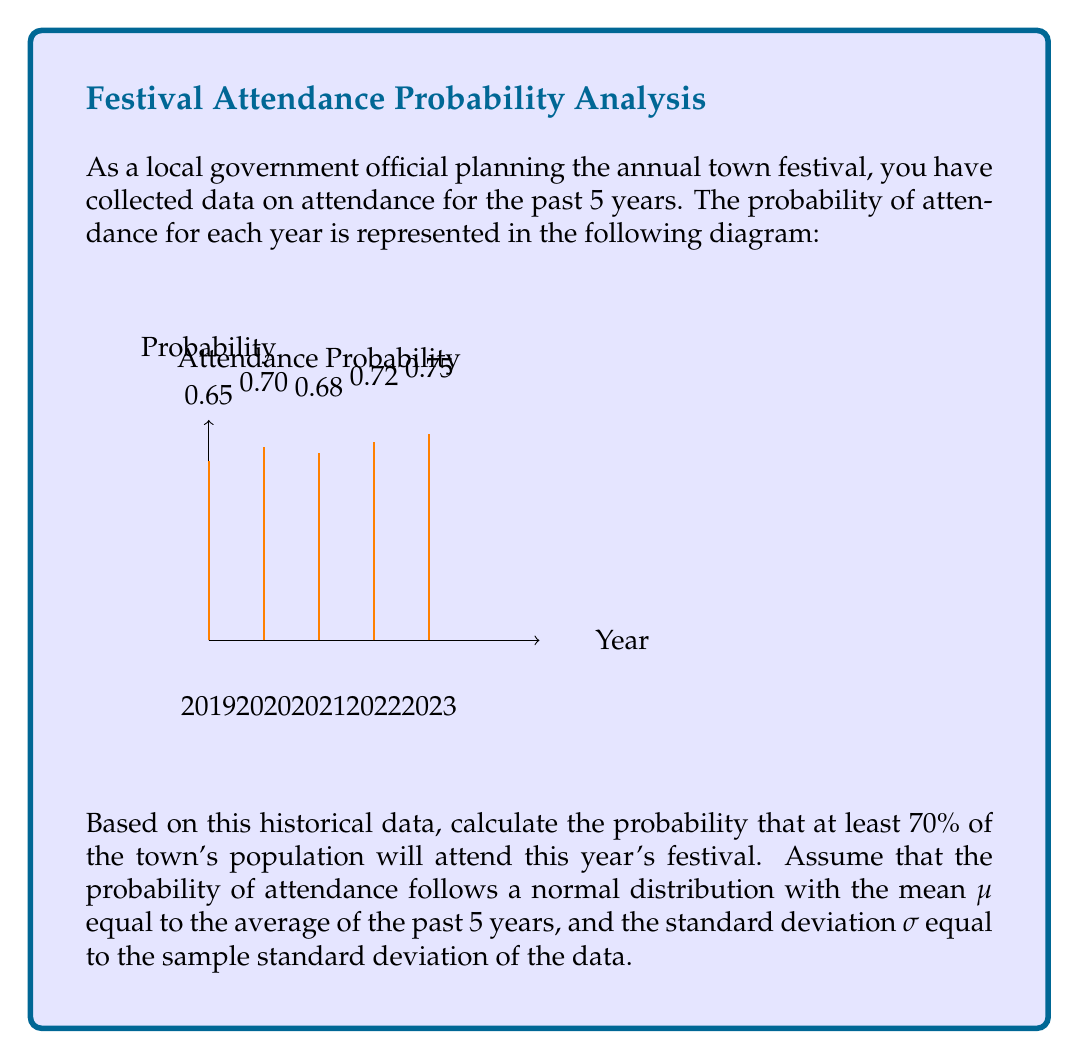Could you help me with this problem? Let's approach this step-by-step:

1) First, calculate the mean $\mu$ of the probabilities:
   $$\mu = \frac{0.65 + 0.70 + 0.68 + 0.72 + 0.75}{5} = 0.70$$

2) Next, calculate the sample standard deviation $\sigma$:
   $$\sigma = \sqrt{\frac{\sum_{i=1}^{n} (x_i - \mu)^2}{n-1}}$$
   where $x_i$ are the individual probabilities and $n=5$.

   $$\sigma = \sqrt{\frac{(-0.05)^2 + 0^2 + (-0.02)^2 + 0.02^2 + 0.05^2}{4}} \approx 0.0374$$

3) We want to find $P(X \geq 0.70)$ where $X$ is normally distributed with $\mu=0.70$ and $\sigma=0.0374$.

4) Standardize the value:
   $$z = \frac{0.70 - \mu}{\sigma} = \frac{0.70 - 0.70}{0.0374} = 0$$

5) The probability we're looking for is the area to the right of $z=0$ on the standard normal distribution, which is 0.5.

Therefore, the probability that at least 70% of the town's population will attend this year's festival is 0.5 or 50%.
Answer: 0.5 